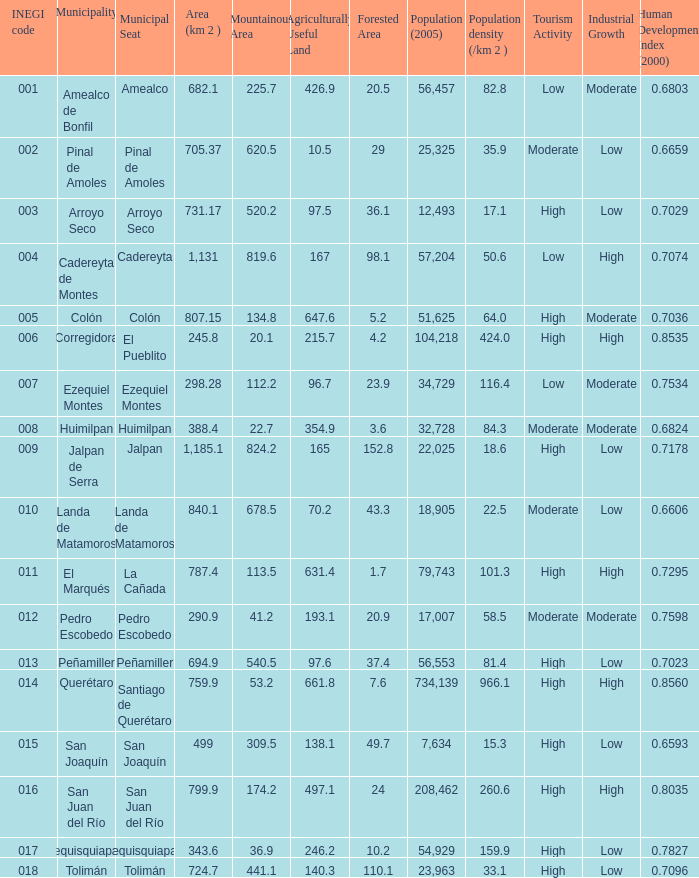WHich INEGI code has a Population density (/km 2 ) smaller than 81.4 and 0.6593 Human Development Index (2000)? 15.0. 